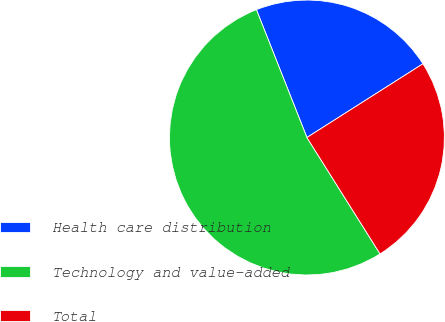Convert chart. <chart><loc_0><loc_0><loc_500><loc_500><pie_chart><fcel>Health care distribution<fcel>Technology and value-added<fcel>Total<nl><fcel>21.98%<fcel>52.94%<fcel>25.08%<nl></chart> 